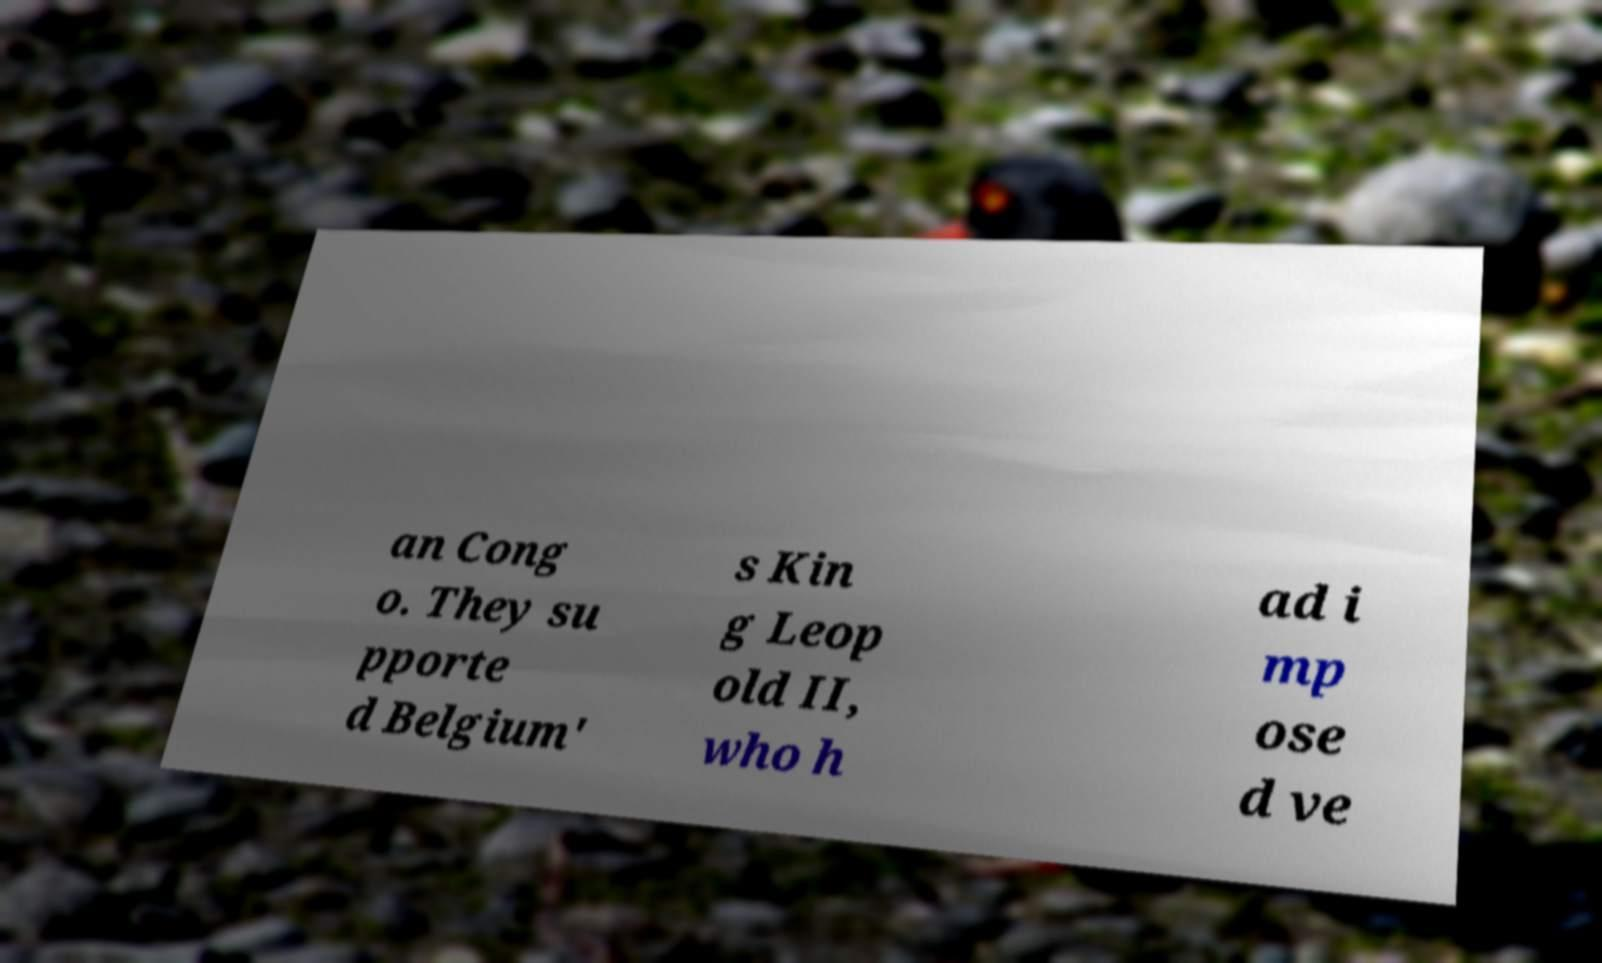Can you accurately transcribe the text from the provided image for me? an Cong o. They su pporte d Belgium' s Kin g Leop old II, who h ad i mp ose d ve 